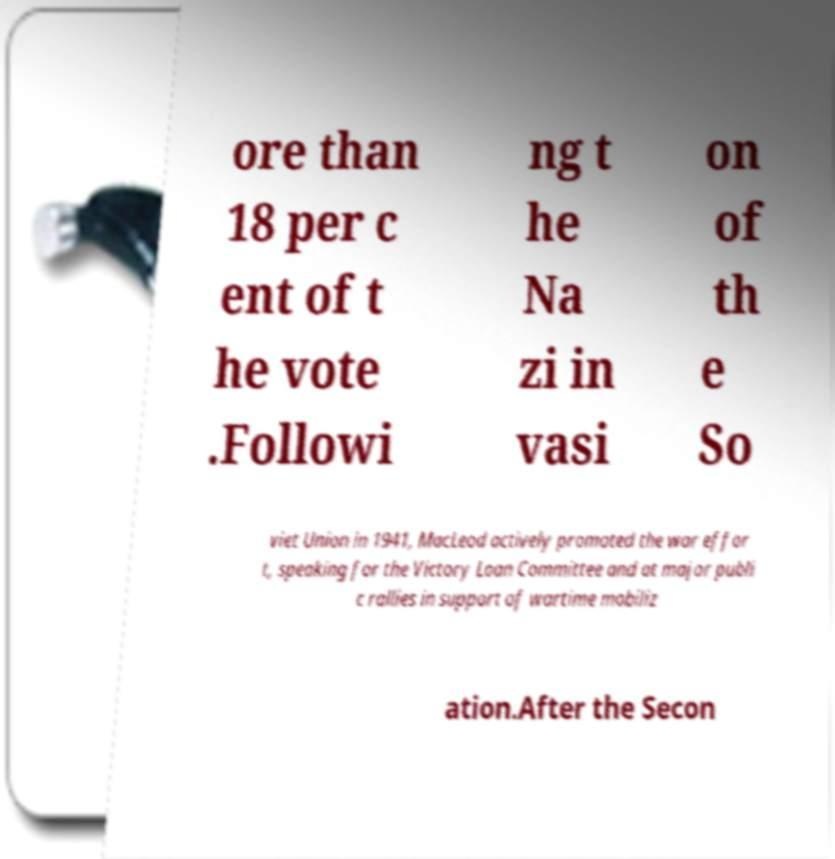Please read and relay the text visible in this image. What does it say? ore than 18 per c ent of t he vote .Followi ng t he Na zi in vasi on of th e So viet Union in 1941, MacLeod actively promoted the war effor t, speaking for the Victory Loan Committee and at major publi c rallies in support of wartime mobiliz ation.After the Secon 